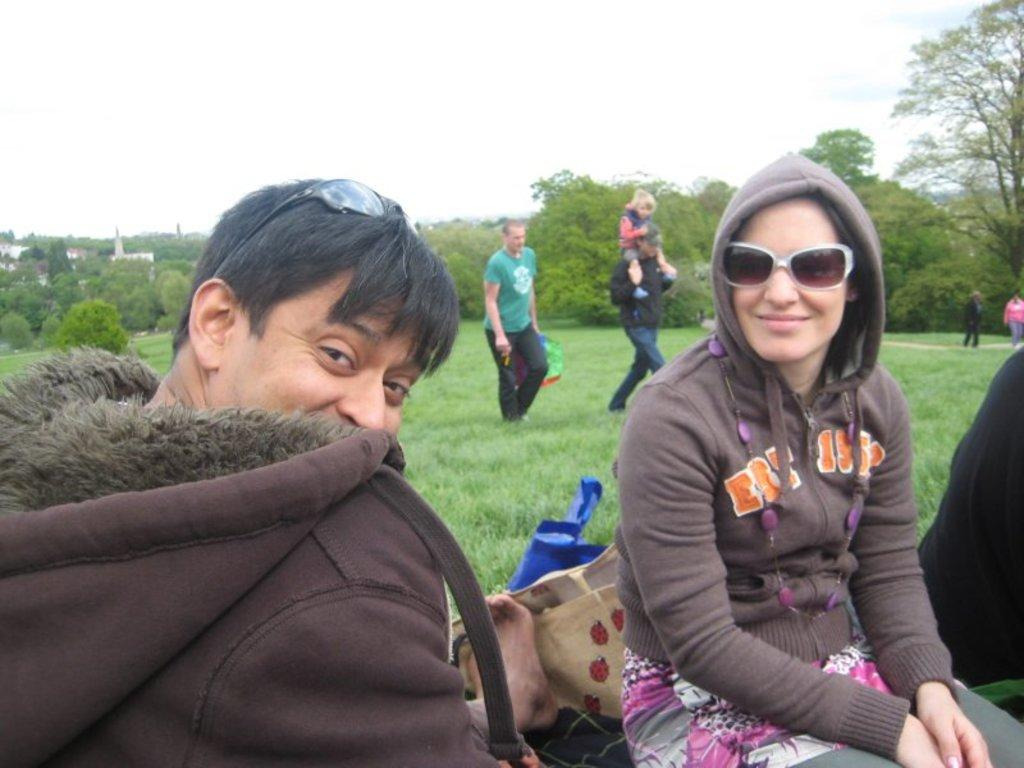Who or what is present in the image? There are people in the image. What objects can be seen with the people? There are bags in the image. What type of natural environment is visible in the image? There is grass and trees in the image. What type of man-made structures can be seen in the image? There are buildings in the image. What is visible in the background of the image? The sky is visible in the background of the image. What type of seed is being planted in the image? There is no seed or planting activity present in the image. What kind of pie is being served in the image? There is no pie present in the image. 